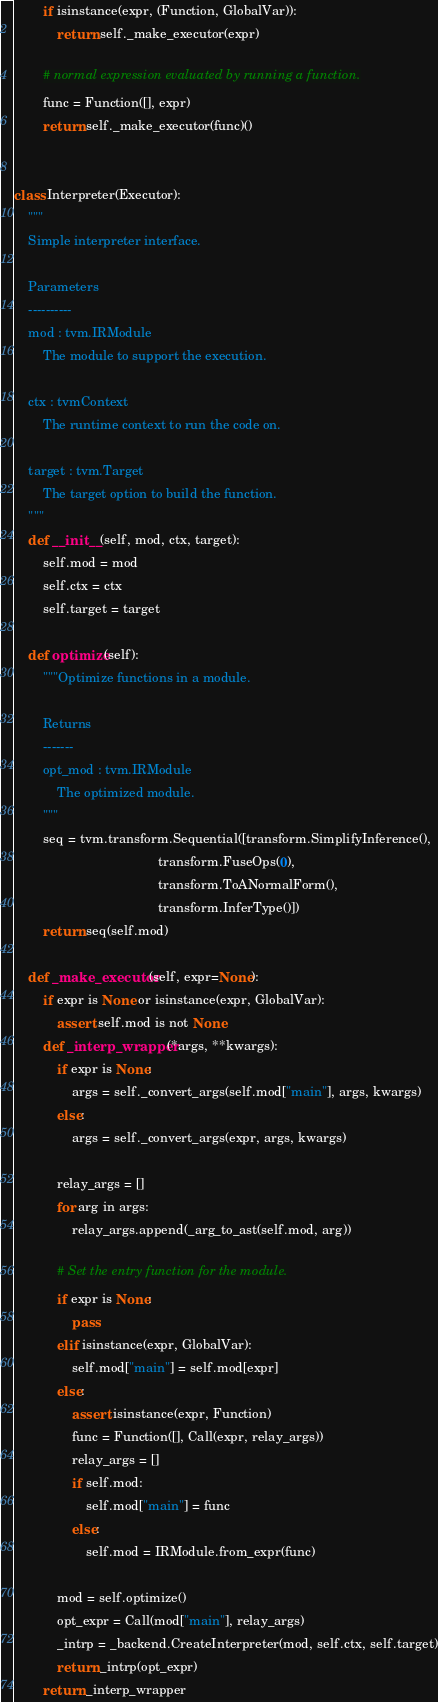Convert code to text. <code><loc_0><loc_0><loc_500><loc_500><_Python_>
        if isinstance(expr, (Function, GlobalVar)):
            return self._make_executor(expr)

        # normal expression evaluated by running a function.
        func = Function([], expr)
        return self._make_executor(func)()


class Interpreter(Executor):
    """
    Simple interpreter interface.

    Parameters
    ----------
    mod : tvm.IRModule
        The module to support the execution.

    ctx : tvmContext
        The runtime context to run the code on.

    target : tvm.Target
        The target option to build the function.
    """
    def __init__(self, mod, ctx, target):
        self.mod = mod
        self.ctx = ctx
        self.target = target

    def optimize(self):
        """Optimize functions in a module.

        Returns
        -------
        opt_mod : tvm.IRModule
            The optimized module.
        """
        seq = tvm.transform.Sequential([transform.SimplifyInference(),
                                        transform.FuseOps(0),
                                        transform.ToANormalForm(),
                                        transform.InferType()])
        return seq(self.mod)

    def _make_executor(self, expr=None):
        if expr is None or isinstance(expr, GlobalVar):
            assert self.mod is not None
        def _interp_wrapper(*args, **kwargs):
            if expr is None:
                args = self._convert_args(self.mod["main"], args, kwargs)
            else:
                args = self._convert_args(expr, args, kwargs)

            relay_args = []
            for arg in args:
                relay_args.append(_arg_to_ast(self.mod, arg))

            # Set the entry function for the module.
            if expr is None:
                pass
            elif isinstance(expr, GlobalVar):
                self.mod["main"] = self.mod[expr]
            else:
                assert isinstance(expr, Function)
                func = Function([], Call(expr, relay_args))
                relay_args = []
                if self.mod:
                    self.mod["main"] = func
                else:
                    self.mod = IRModule.from_expr(func)

            mod = self.optimize()
            opt_expr = Call(mod["main"], relay_args)
            _intrp = _backend.CreateInterpreter(mod, self.ctx, self.target)
            return _intrp(opt_expr)
        return _interp_wrapper
</code> 